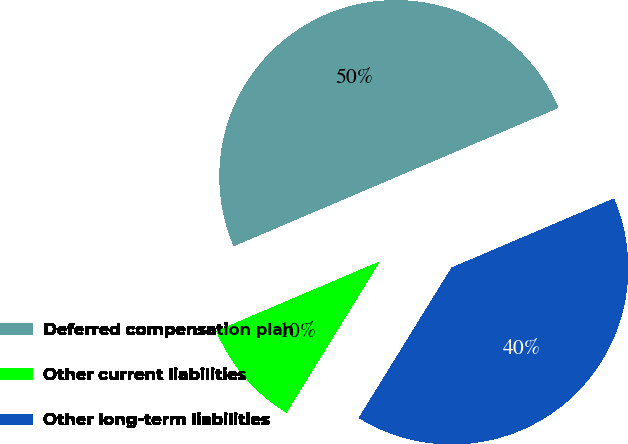Convert chart to OTSL. <chart><loc_0><loc_0><loc_500><loc_500><pie_chart><fcel>Deferred compensation plan<fcel>Other current liabilities<fcel>Other long-term liabilities<nl><fcel>50.0%<fcel>9.79%<fcel>40.21%<nl></chart> 